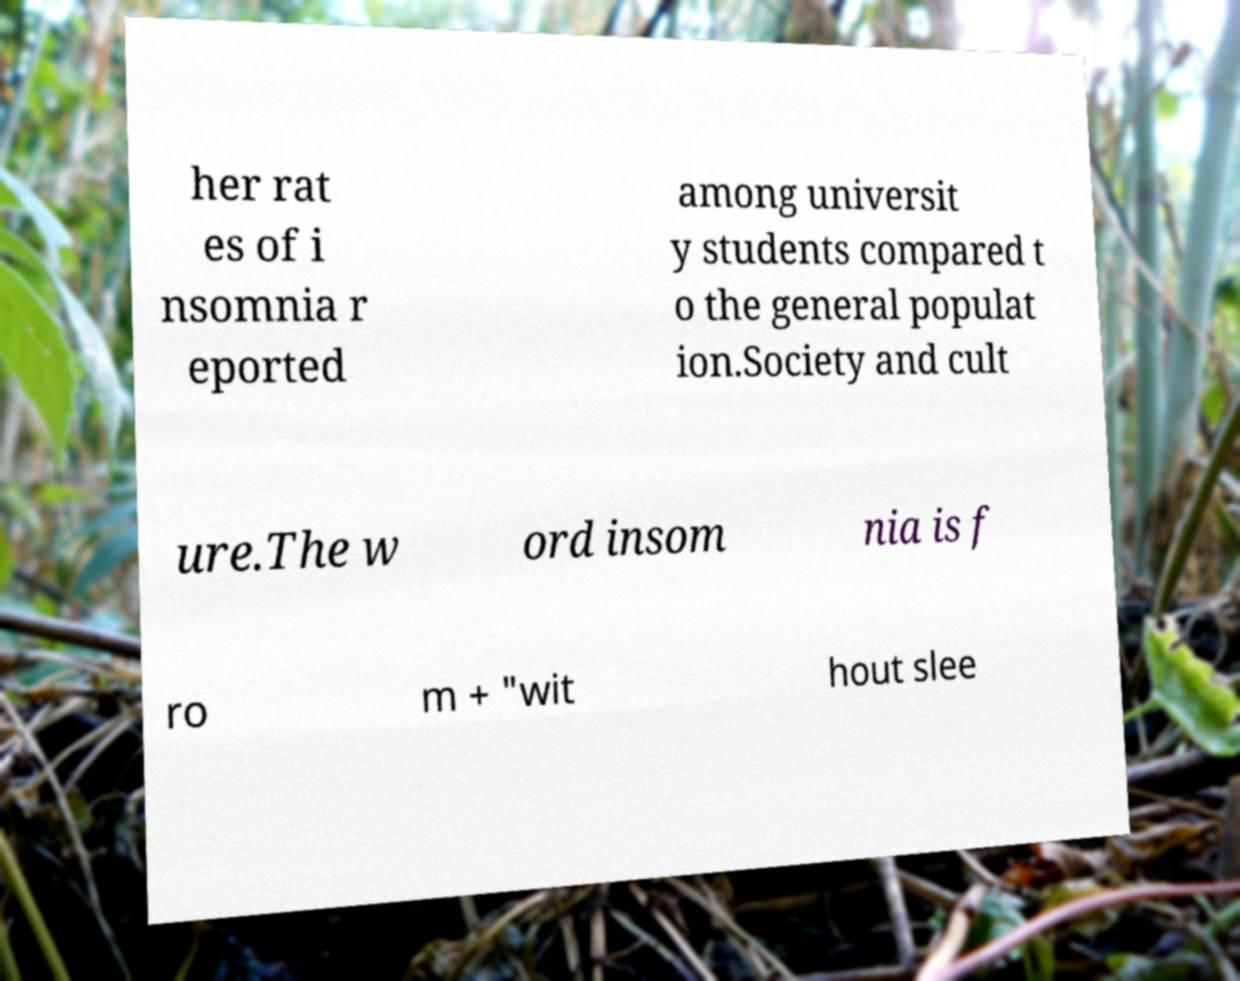Can you read and provide the text displayed in the image?This photo seems to have some interesting text. Can you extract and type it out for me? her rat es of i nsomnia r eported among universit y students compared t o the general populat ion.Society and cult ure.The w ord insom nia is f ro m + "wit hout slee 